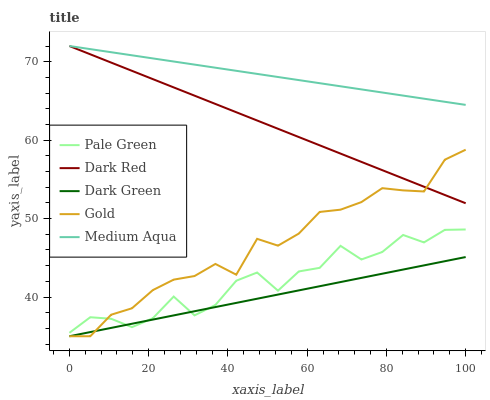Does Dark Green have the minimum area under the curve?
Answer yes or no. Yes. Does Medium Aqua have the maximum area under the curve?
Answer yes or no. Yes. Does Pale Green have the minimum area under the curve?
Answer yes or no. No. Does Pale Green have the maximum area under the curve?
Answer yes or no. No. Is Dark Green the smoothest?
Answer yes or no. Yes. Is Pale Green the roughest?
Answer yes or no. Yes. Is Medium Aqua the smoothest?
Answer yes or no. No. Is Medium Aqua the roughest?
Answer yes or no. No. Does Gold have the lowest value?
Answer yes or no. Yes. Does Pale Green have the lowest value?
Answer yes or no. No. Does Medium Aqua have the highest value?
Answer yes or no. Yes. Does Pale Green have the highest value?
Answer yes or no. No. Is Pale Green less than Dark Red?
Answer yes or no. Yes. Is Medium Aqua greater than Dark Green?
Answer yes or no. Yes. Does Dark Red intersect Medium Aqua?
Answer yes or no. Yes. Is Dark Red less than Medium Aqua?
Answer yes or no. No. Is Dark Red greater than Medium Aqua?
Answer yes or no. No. Does Pale Green intersect Dark Red?
Answer yes or no. No. 